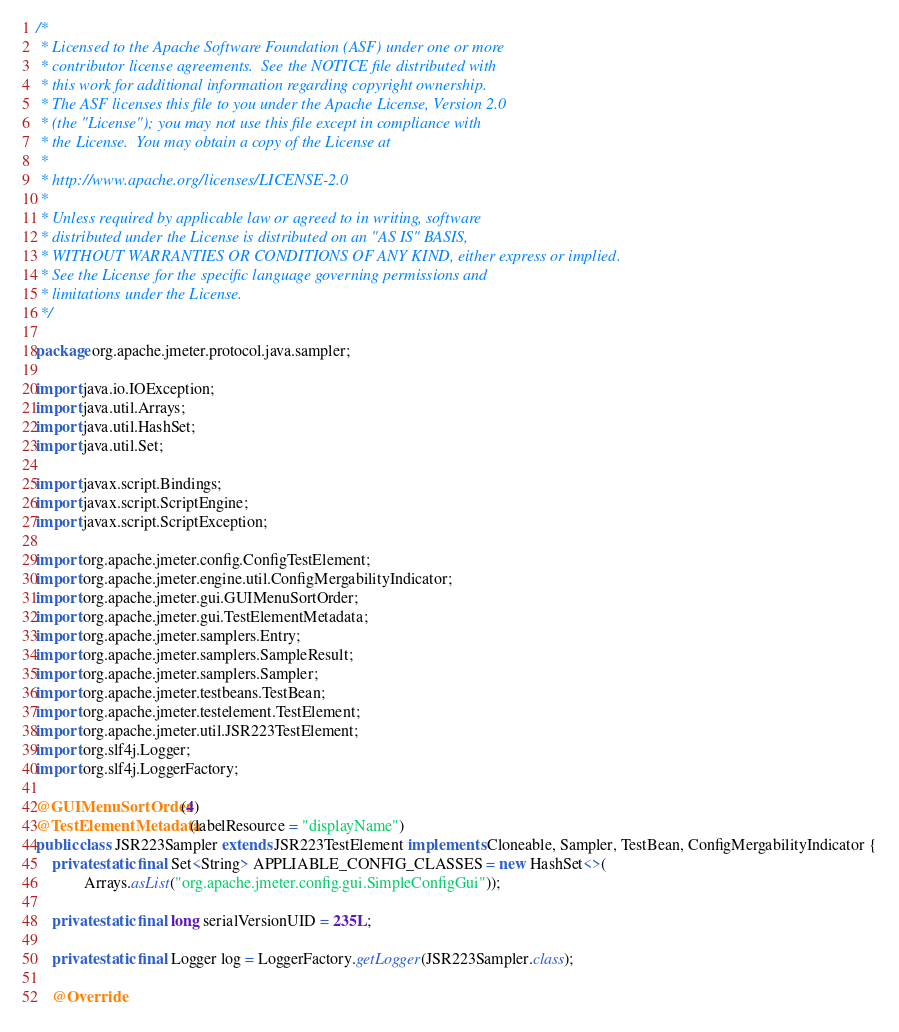Convert code to text. <code><loc_0><loc_0><loc_500><loc_500><_Java_>/*
 * Licensed to the Apache Software Foundation (ASF) under one or more
 * contributor license agreements.  See the NOTICE file distributed with
 * this work for additional information regarding copyright ownership.
 * The ASF licenses this file to you under the Apache License, Version 2.0
 * (the "License"); you may not use this file except in compliance with
 * the License.  You may obtain a copy of the License at
 *
 * http://www.apache.org/licenses/LICENSE-2.0
 *
 * Unless required by applicable law or agreed to in writing, software
 * distributed under the License is distributed on an "AS IS" BASIS,
 * WITHOUT WARRANTIES OR CONDITIONS OF ANY KIND, either express or implied.
 * See the License for the specific language governing permissions and
 * limitations under the License.
 */

package org.apache.jmeter.protocol.java.sampler;

import java.io.IOException;
import java.util.Arrays;
import java.util.HashSet;
import java.util.Set;

import javax.script.Bindings;
import javax.script.ScriptEngine;
import javax.script.ScriptException;

import org.apache.jmeter.config.ConfigTestElement;
import org.apache.jmeter.engine.util.ConfigMergabilityIndicator;
import org.apache.jmeter.gui.GUIMenuSortOrder;
import org.apache.jmeter.gui.TestElementMetadata;
import org.apache.jmeter.samplers.Entry;
import org.apache.jmeter.samplers.SampleResult;
import org.apache.jmeter.samplers.Sampler;
import org.apache.jmeter.testbeans.TestBean;
import org.apache.jmeter.testelement.TestElement;
import org.apache.jmeter.util.JSR223TestElement;
import org.slf4j.Logger;
import org.slf4j.LoggerFactory;

@GUIMenuSortOrder(4)
@TestElementMetadata(labelResource = "displayName")
public class JSR223Sampler extends JSR223TestElement implements Cloneable, Sampler, TestBean, ConfigMergabilityIndicator {
    private static final Set<String> APPLIABLE_CONFIG_CLASSES = new HashSet<>(
            Arrays.asList("org.apache.jmeter.config.gui.SimpleConfigGui"));

    private static final long serialVersionUID = 235L;

    private static final Logger log = LoggerFactory.getLogger(JSR223Sampler.class);

    @Override</code> 